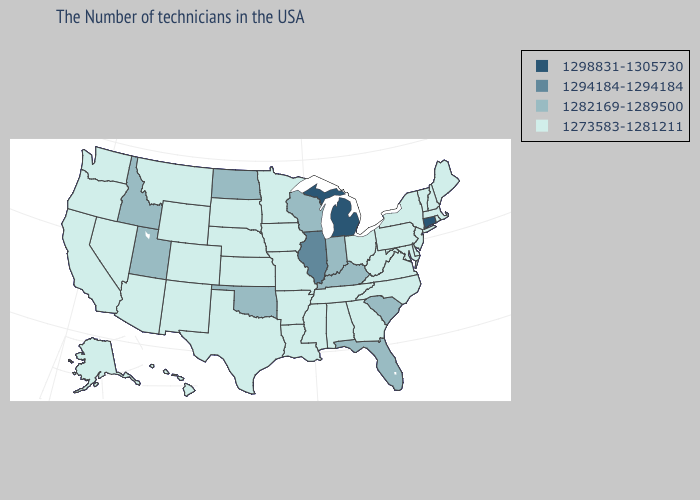Does Colorado have a lower value than Iowa?
Be succinct. No. Does the map have missing data?
Be succinct. No. Among the states that border Michigan , does Wisconsin have the highest value?
Quick response, please. Yes. Name the states that have a value in the range 1294184-1294184?
Concise answer only. Illinois. Does Oregon have the lowest value in the West?
Quick response, please. Yes. Does Connecticut have the highest value in the Northeast?
Keep it brief. Yes. Does California have a lower value than Iowa?
Write a very short answer. No. What is the value of Alabama?
Write a very short answer. 1273583-1281211. Which states hav the highest value in the West?
Write a very short answer. Utah, Idaho. What is the value of Minnesota?
Concise answer only. 1273583-1281211. What is the highest value in the USA?
Keep it brief. 1298831-1305730. What is the highest value in the USA?
Concise answer only. 1298831-1305730. Does Wyoming have the lowest value in the USA?
Keep it brief. Yes. Does Texas have a lower value than Kansas?
Give a very brief answer. No. Which states have the lowest value in the USA?
Write a very short answer. Maine, Massachusetts, Rhode Island, New Hampshire, Vermont, New York, New Jersey, Delaware, Maryland, Pennsylvania, Virginia, North Carolina, West Virginia, Ohio, Georgia, Alabama, Tennessee, Mississippi, Louisiana, Missouri, Arkansas, Minnesota, Iowa, Kansas, Nebraska, Texas, South Dakota, Wyoming, Colorado, New Mexico, Montana, Arizona, Nevada, California, Washington, Oregon, Alaska, Hawaii. 